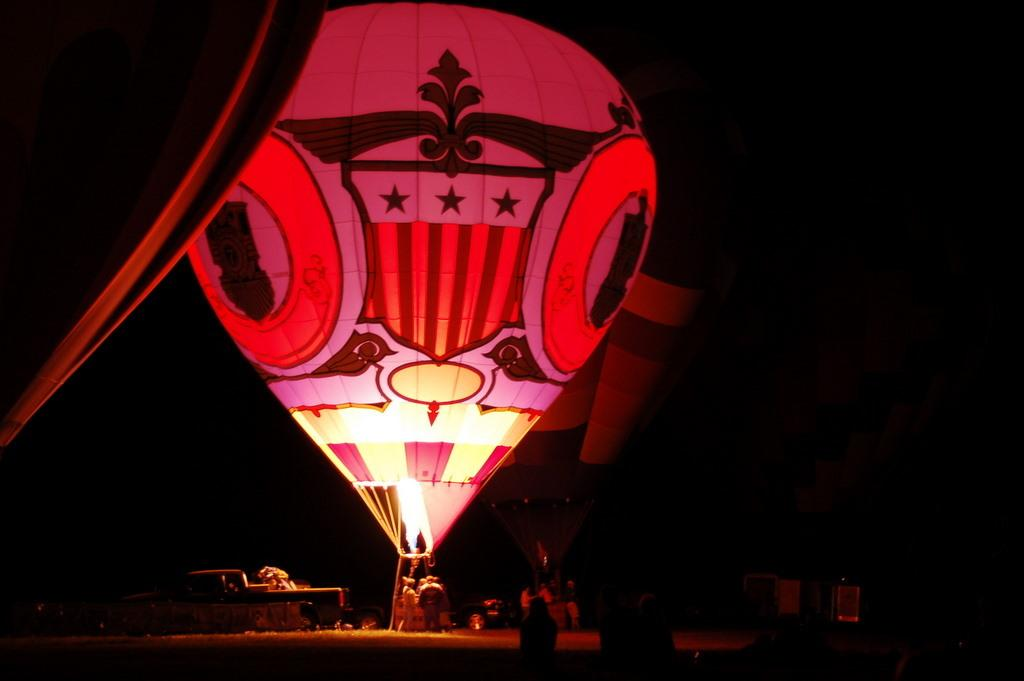What is the main subject in the center of the image? There are parachutes in the center of the image. What is located at the bottom of the image? There is a group of people at the bottom of the image. What else can be seen at the bottom of the image? There are objects present at the bottom of the image. How would you describe the overall lighting in the image? The background of the image is dark. Can you tell me how many basketballs are being used by the daughter in the image? There is no daughter or basketball present in the image. 